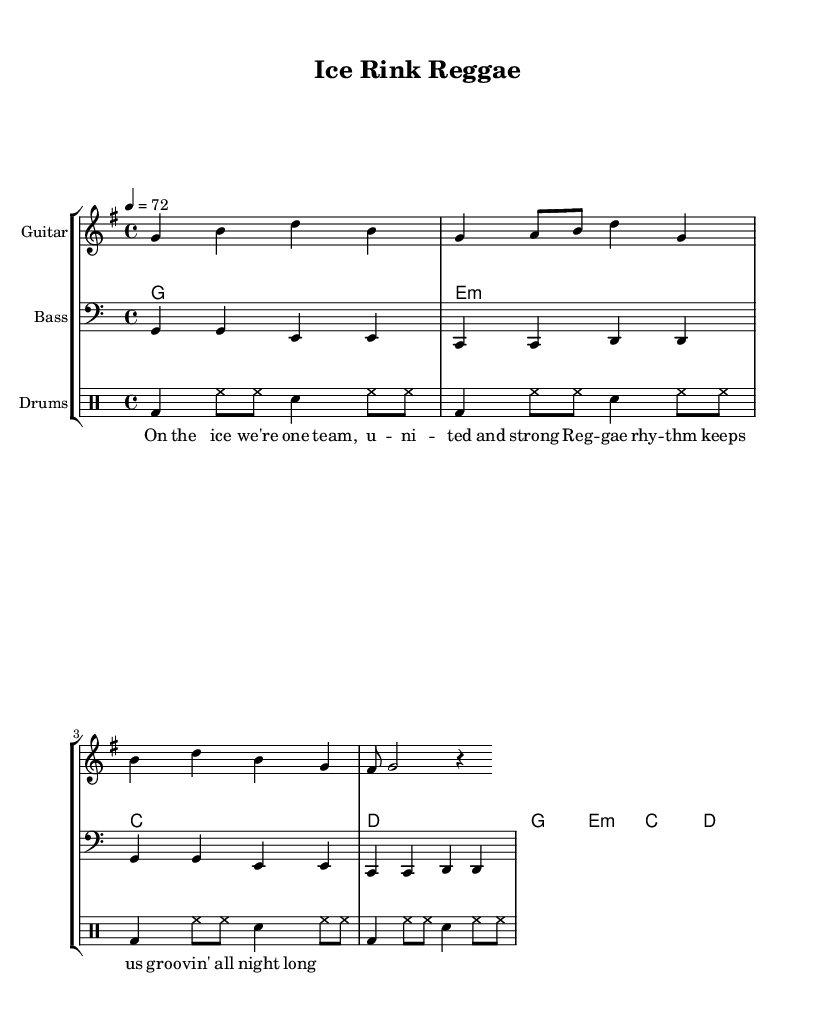What is the key signature of this music? The key signature is G major, which has one sharp (F#). This can be found at the beginning of the staff, indicating to musicians which notes should be played sharp throughout the piece.
Answer: G major What is the time signature of this music? The time signature is 4/4, indicated below the key signature on the staff. This means there are four beats in each measure, and the quarter note receives one beat.
Answer: 4/4 What is the tempo marking for this music? The tempo marking is 72 beats per minute, shown in textual form at the beginning of the piece. This indicates how fast the music should be played.
Answer: 72 How many measures does the melody have? The melody consists of four measures, which can be counted based on the notation in the melody staff. Each segment divided by vertical lines represents a measure.
Answer: Four Which instruments are included in the score? The instruments included are guitar, bass, and drums, as specified at the beginning of each staff within the score. This indicates the different musical parts being played.
Answer: Guitar, bass, drums What is the main theme expressed in the lyrics? The main theme is team spirit, as indicated by lyrics discussing unity and strength on the ice. The lyrics reflect a sense of camaraderie that is typical in a reggae context.
Answer: Team spirit How does the rhythm reflect the reggae style? The rhythm features off-beat accents characterized by the reggae style, which combines syncopation and a laid-back groove, making it distinctively feel relaxed yet strong. This can be identified through the rhythmic structure notated in the score.
Answer: Laid-back groove 